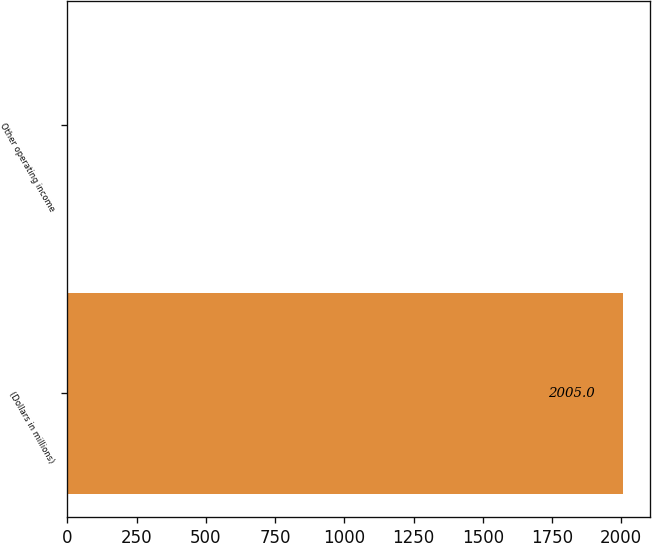<chart> <loc_0><loc_0><loc_500><loc_500><bar_chart><fcel>(Dollars in millions)<fcel>Other operating income<nl><fcel>2005<fcel>2<nl></chart> 